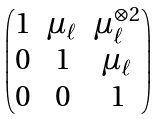Convert formula to latex. <formula><loc_0><loc_0><loc_500><loc_500>\begin{pmatrix} 1 & \mu _ { \ell } & \mu _ { \ell } ^ { \otimes 2 } \\ 0 & 1 & \mu _ { \ell } \\ 0 & 0 & 1 \end{pmatrix}</formula> 